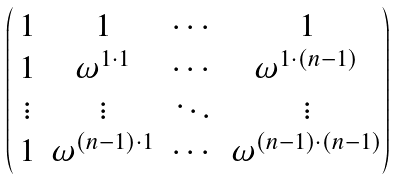<formula> <loc_0><loc_0><loc_500><loc_500>\begin{pmatrix} \, 1 & 1 & \cdots & 1 \\ \, 1 & \omega ^ { 1 \cdot 1 } & \cdots & \omega ^ { 1 \cdot ( n - 1 ) } \\ \, \vdots & \vdots & \ddots & \vdots \\ \, 1 & \omega ^ { ( n - 1 ) \cdot 1 } & \cdots & \omega ^ { ( n - 1 ) \cdot ( n - 1 ) } \end{pmatrix}</formula> 